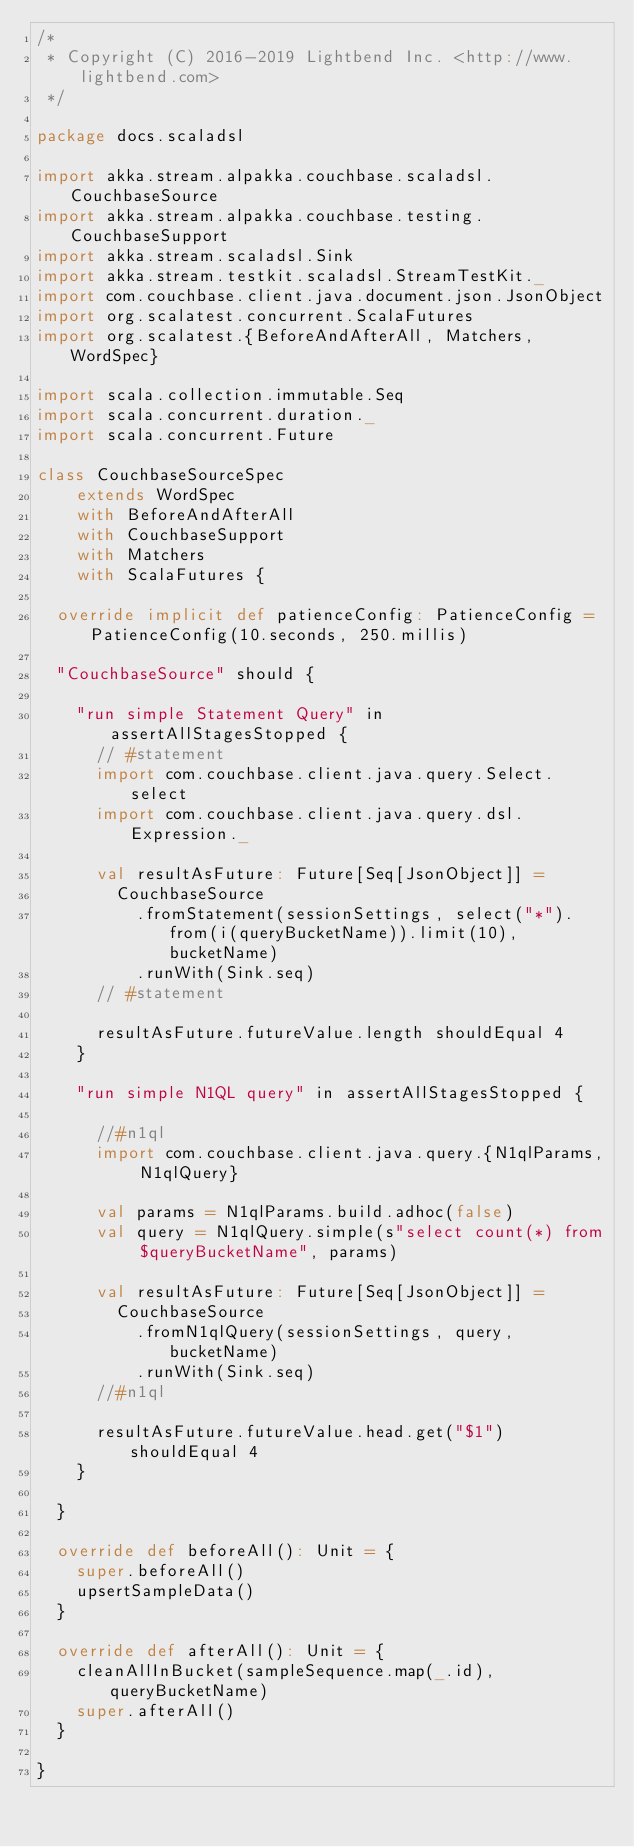<code> <loc_0><loc_0><loc_500><loc_500><_Scala_>/*
 * Copyright (C) 2016-2019 Lightbend Inc. <http://www.lightbend.com>
 */

package docs.scaladsl

import akka.stream.alpakka.couchbase.scaladsl.CouchbaseSource
import akka.stream.alpakka.couchbase.testing.CouchbaseSupport
import akka.stream.scaladsl.Sink
import akka.stream.testkit.scaladsl.StreamTestKit._
import com.couchbase.client.java.document.json.JsonObject
import org.scalatest.concurrent.ScalaFutures
import org.scalatest.{BeforeAndAfterAll, Matchers, WordSpec}

import scala.collection.immutable.Seq
import scala.concurrent.duration._
import scala.concurrent.Future

class CouchbaseSourceSpec
    extends WordSpec
    with BeforeAndAfterAll
    with CouchbaseSupport
    with Matchers
    with ScalaFutures {

  override implicit def patienceConfig: PatienceConfig = PatienceConfig(10.seconds, 250.millis)

  "CouchbaseSource" should {

    "run simple Statement Query" in assertAllStagesStopped {
      // #statement
      import com.couchbase.client.java.query.Select.select
      import com.couchbase.client.java.query.dsl.Expression._

      val resultAsFuture: Future[Seq[JsonObject]] =
        CouchbaseSource
          .fromStatement(sessionSettings, select("*").from(i(queryBucketName)).limit(10), bucketName)
          .runWith(Sink.seq)
      // #statement

      resultAsFuture.futureValue.length shouldEqual 4
    }

    "run simple N1QL query" in assertAllStagesStopped {

      //#n1ql
      import com.couchbase.client.java.query.{N1qlParams, N1qlQuery}

      val params = N1qlParams.build.adhoc(false)
      val query = N1qlQuery.simple(s"select count(*) from $queryBucketName", params)

      val resultAsFuture: Future[Seq[JsonObject]] =
        CouchbaseSource
          .fromN1qlQuery(sessionSettings, query, bucketName)
          .runWith(Sink.seq)
      //#n1ql

      resultAsFuture.futureValue.head.get("$1") shouldEqual 4
    }

  }

  override def beforeAll(): Unit = {
    super.beforeAll()
    upsertSampleData()
  }

  override def afterAll(): Unit = {
    cleanAllInBucket(sampleSequence.map(_.id), queryBucketName)
    super.afterAll()
  }

}
</code> 